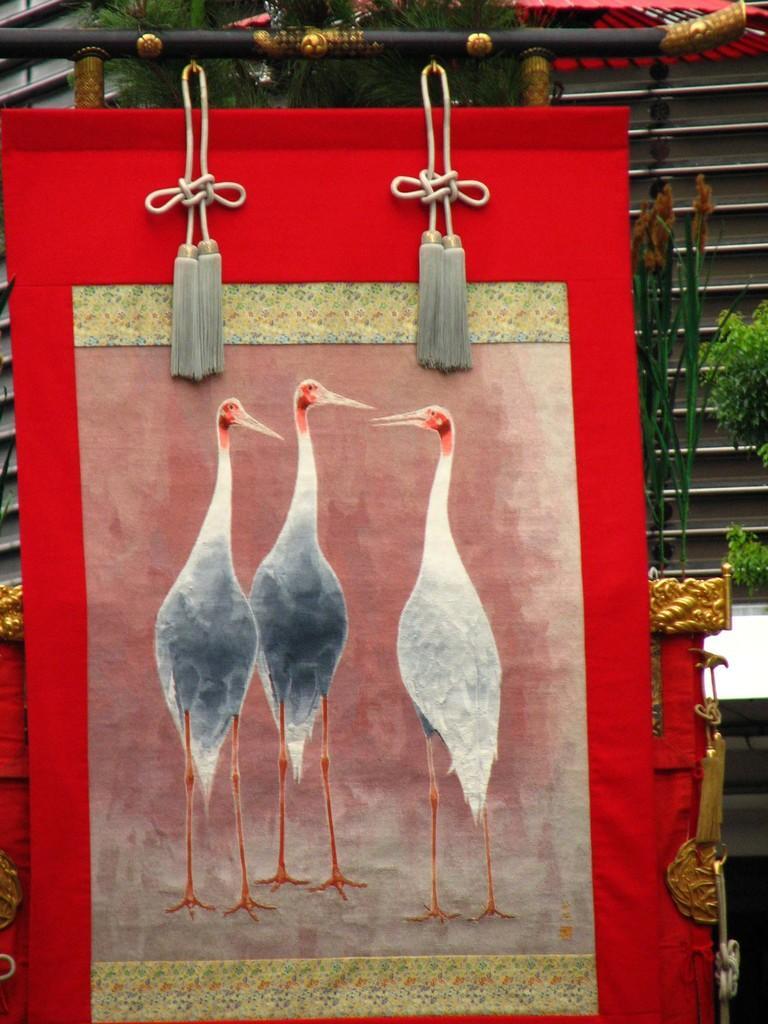In one or two sentences, can you explain what this image depicts? There is a red color frame. On that there is a painting of three cranes. And the frame is hanged with ropes. And there is a stand. In the background there is a plant on the right side. 